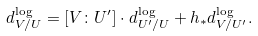Convert formula to latex. <formula><loc_0><loc_0><loc_500><loc_500>d ^ { \log } _ { V / U } = [ V \colon U ^ { \prime } ] \cdot d ^ { \log } _ { U ^ { \prime } / U } + h _ { * } d ^ { \log } _ { V / U ^ { \prime } } .</formula> 